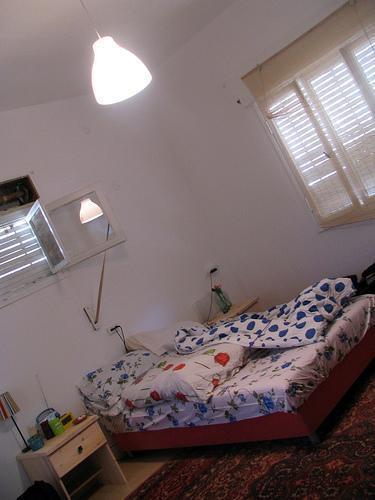How many cats there?
Give a very brief answer. 0. 